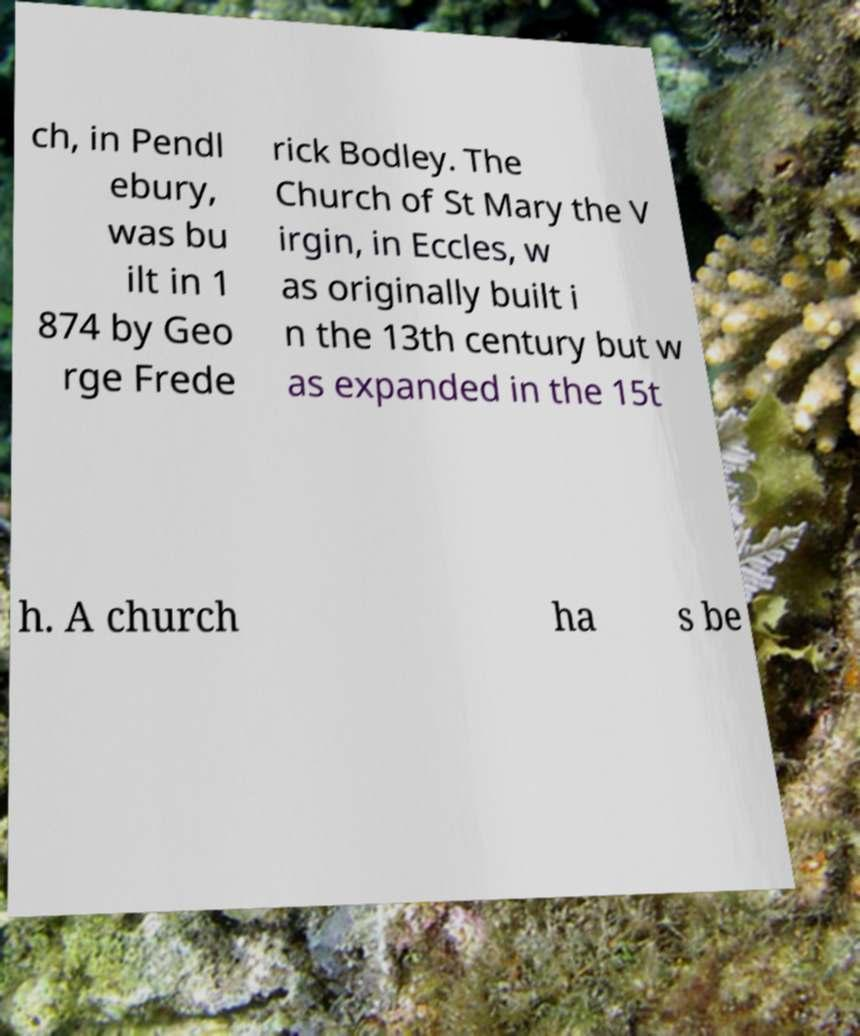I need the written content from this picture converted into text. Can you do that? ch, in Pendl ebury, was bu ilt in 1 874 by Geo rge Frede rick Bodley. The Church of St Mary the V irgin, in Eccles, w as originally built i n the 13th century but w as expanded in the 15t h. A church ha s be 